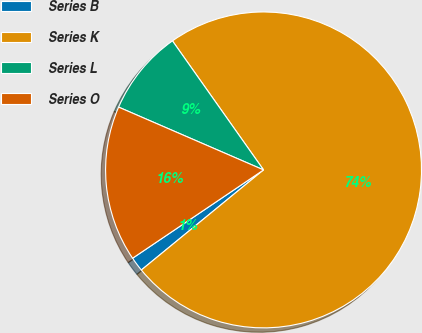Convert chart. <chart><loc_0><loc_0><loc_500><loc_500><pie_chart><fcel>Series B<fcel>Series K<fcel>Series L<fcel>Series O<nl><fcel>1.48%<fcel>73.86%<fcel>8.71%<fcel>15.95%<nl></chart> 